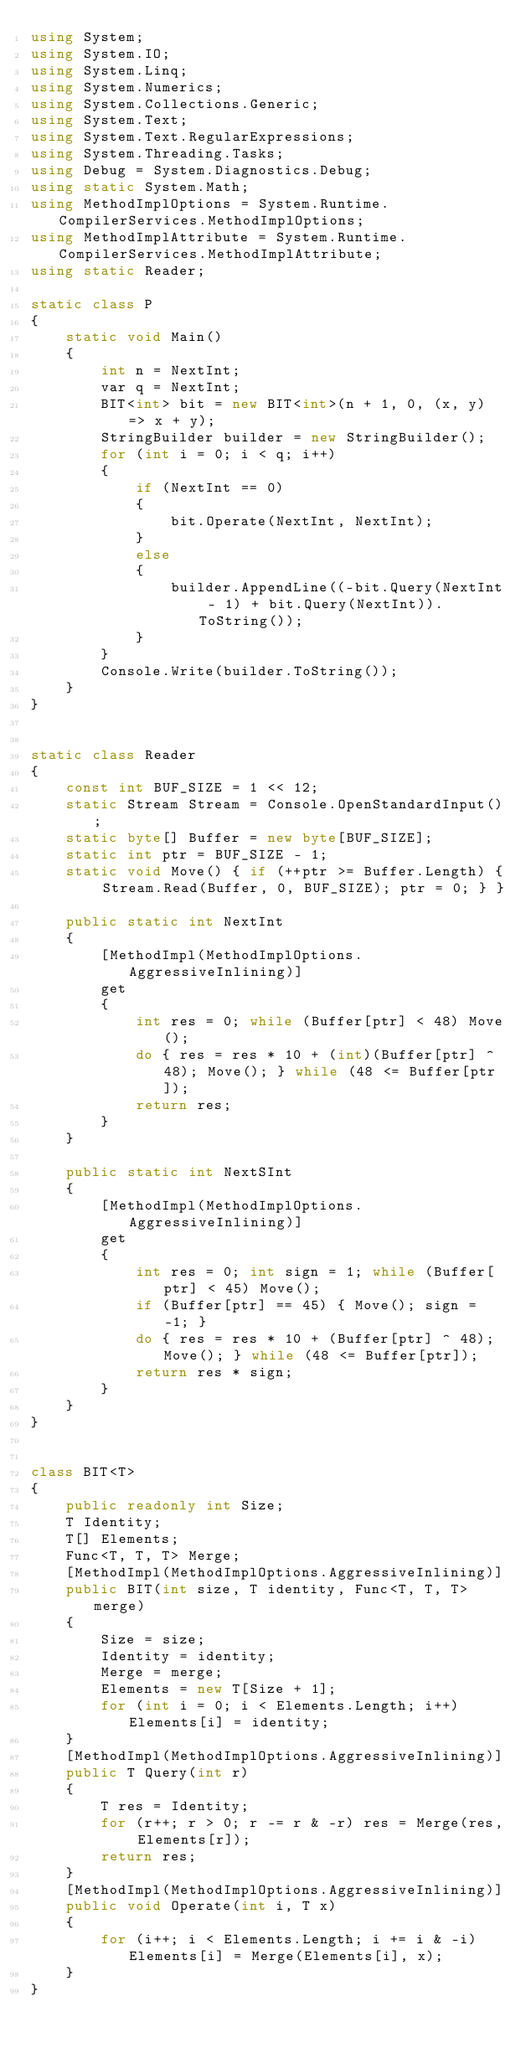Convert code to text. <code><loc_0><loc_0><loc_500><loc_500><_C#_>using System;
using System.IO;
using System.Linq;
using System.Numerics;
using System.Collections.Generic;
using System.Text;
using System.Text.RegularExpressions;
using System.Threading.Tasks;
using Debug = System.Diagnostics.Debug;
using static System.Math;
using MethodImplOptions = System.Runtime.CompilerServices.MethodImplOptions;
using MethodImplAttribute = System.Runtime.CompilerServices.MethodImplAttribute;
using static Reader;

static class P
{
    static void Main()
    {
        int n = NextInt;
        var q = NextInt;
        BIT<int> bit = new BIT<int>(n + 1, 0, (x, y) => x + y);
        StringBuilder builder = new StringBuilder();
        for (int i = 0; i < q; i++)
        {
            if (NextInt == 0)
            {
                bit.Operate(NextInt, NextInt);
            }
            else
            {
                builder.AppendLine((-bit.Query(NextInt - 1) + bit.Query(NextInt)).ToString());
            }
        }
        Console.Write(builder.ToString());
    }
}


static class Reader
{
    const int BUF_SIZE = 1 << 12;
    static Stream Stream = Console.OpenStandardInput();
    static byte[] Buffer = new byte[BUF_SIZE];
    static int ptr = BUF_SIZE - 1;
    static void Move() { if (++ptr >= Buffer.Length) { Stream.Read(Buffer, 0, BUF_SIZE); ptr = 0; } }

    public static int NextInt
    {
        [MethodImpl(MethodImplOptions.AggressiveInlining)]
        get
        {
            int res = 0; while (Buffer[ptr] < 48) Move();
            do { res = res * 10 + (int)(Buffer[ptr] ^ 48); Move(); } while (48 <= Buffer[ptr]);
            return res;
        }
    }

    public static int NextSInt
    {
        [MethodImpl(MethodImplOptions.AggressiveInlining)]
        get
        {
            int res = 0; int sign = 1; while (Buffer[ptr] < 45) Move();
            if (Buffer[ptr] == 45) { Move(); sign = -1; }
            do { res = res * 10 + (Buffer[ptr] ^ 48); Move(); } while (48 <= Buffer[ptr]);
            return res * sign;
        }
    }
}


class BIT<T>
{
    public readonly int Size;
    T Identity;
    T[] Elements;
    Func<T, T, T> Merge;
    [MethodImpl(MethodImplOptions.AggressiveInlining)]
    public BIT(int size, T identity, Func<T, T, T> merge)
    {
        Size = size;
        Identity = identity;
        Merge = merge;
        Elements = new T[Size + 1];
        for (int i = 0; i < Elements.Length; i++) Elements[i] = identity;
    }
    [MethodImpl(MethodImplOptions.AggressiveInlining)]
    public T Query(int r)
    {
        T res = Identity;
        for (r++; r > 0; r -= r & -r) res = Merge(res, Elements[r]);
        return res;
    }
    [MethodImpl(MethodImplOptions.AggressiveInlining)]
    public void Operate(int i, T x)
    {
        for (i++; i < Elements.Length; i += i & -i) Elements[i] = Merge(Elements[i], x);
    }
}

</code> 